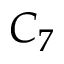Convert formula to latex. <formula><loc_0><loc_0><loc_500><loc_500>C _ { 7 }</formula> 